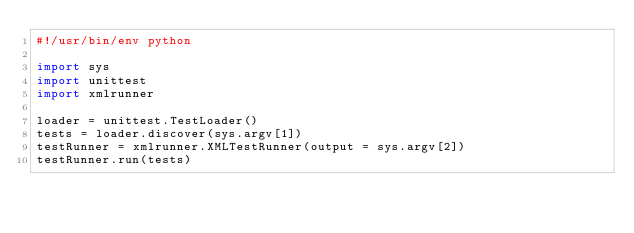Convert code to text. <code><loc_0><loc_0><loc_500><loc_500><_Python_>#!/usr/bin/env python

import sys
import unittest
import xmlrunner

loader = unittest.TestLoader()
tests = loader.discover(sys.argv[1])
testRunner = xmlrunner.XMLTestRunner(output = sys.argv[2])
testRunner.run(tests)
</code> 